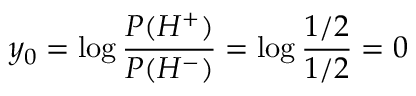<formula> <loc_0><loc_0><loc_500><loc_500>y _ { 0 } = \log \frac { P ( H ^ { + } ) } { P ( H ^ { - } ) } = \log \frac { 1 / 2 } { 1 / 2 } = 0</formula> 